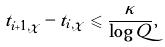<formula> <loc_0><loc_0><loc_500><loc_500>t _ { i + 1 , \chi } - t _ { i , \chi } \leqslant \frac { \kappa } { \log Q } ,</formula> 